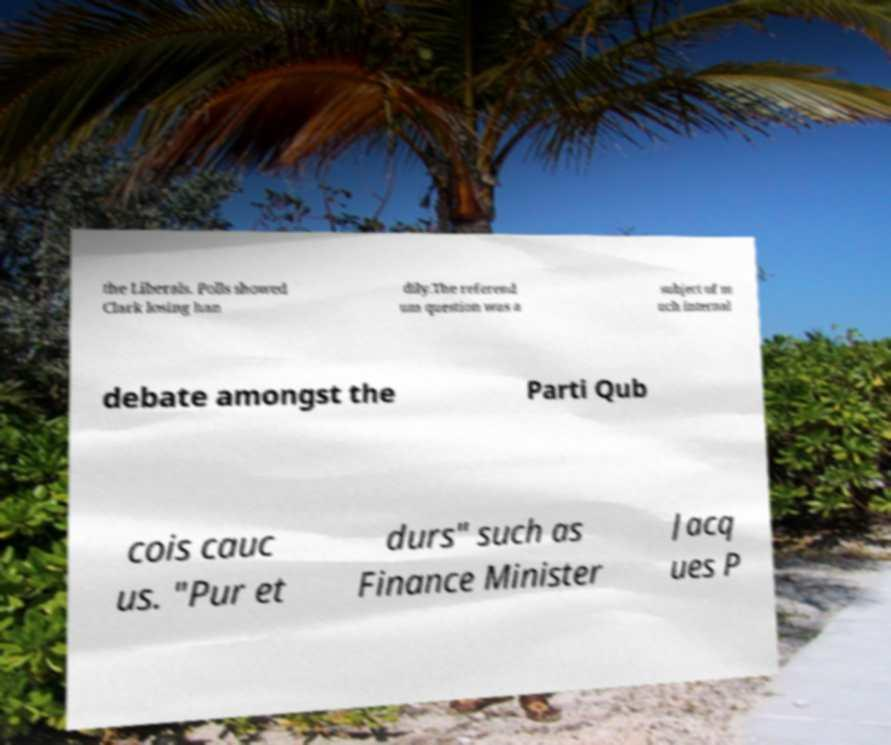Can you accurately transcribe the text from the provided image for me? the Liberals. Polls showed Clark losing han dily.The referend um question was a subject of m uch internal debate amongst the Parti Qub cois cauc us. "Pur et durs" such as Finance Minister Jacq ues P 